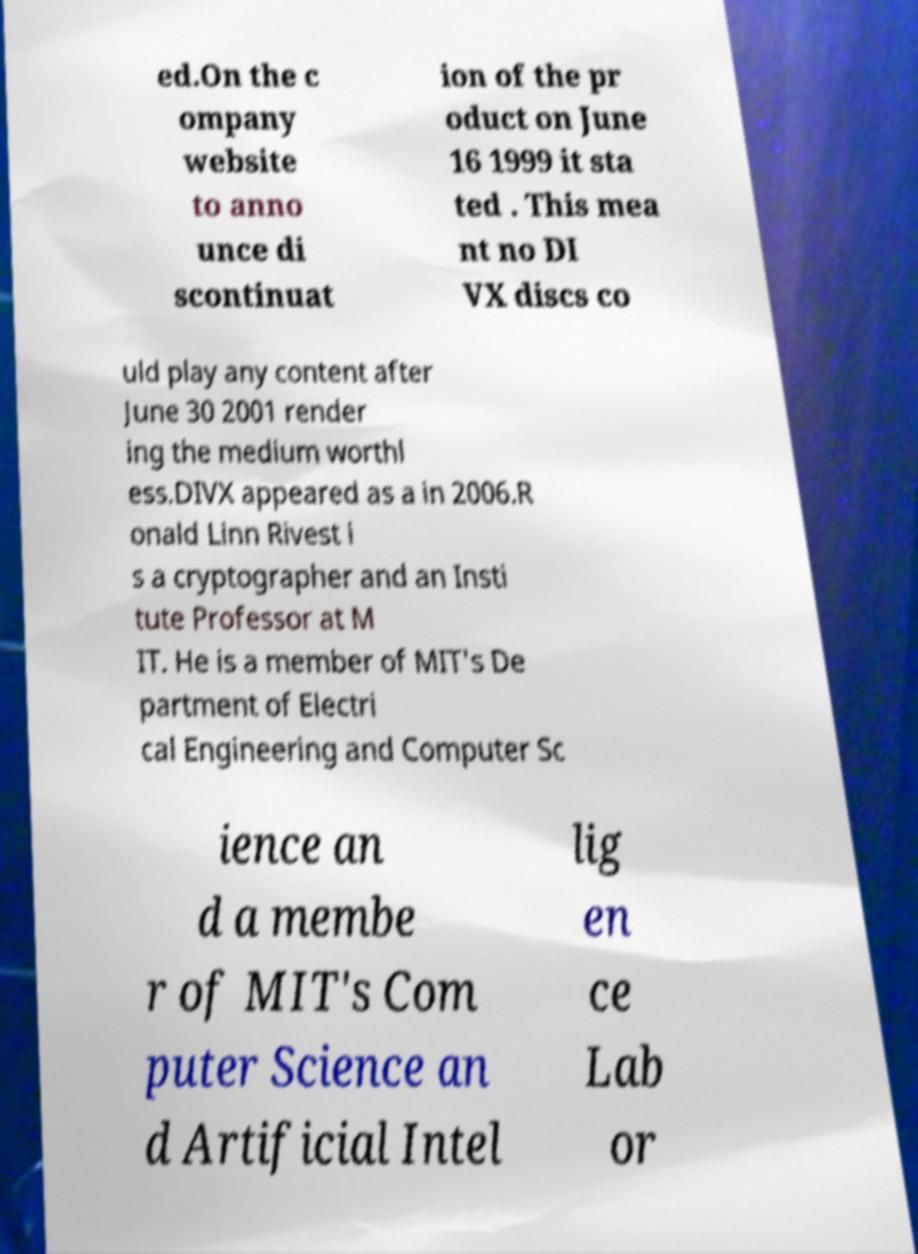Can you read and provide the text displayed in the image?This photo seems to have some interesting text. Can you extract and type it out for me? ed.On the c ompany website to anno unce di scontinuat ion of the pr oduct on June 16 1999 it sta ted . This mea nt no DI VX discs co uld play any content after June 30 2001 render ing the medium worthl ess.DIVX appeared as a in 2006.R onald Linn Rivest i s a cryptographer and an Insti tute Professor at M IT. He is a member of MIT's De partment of Electri cal Engineering and Computer Sc ience an d a membe r of MIT's Com puter Science an d Artificial Intel lig en ce Lab or 